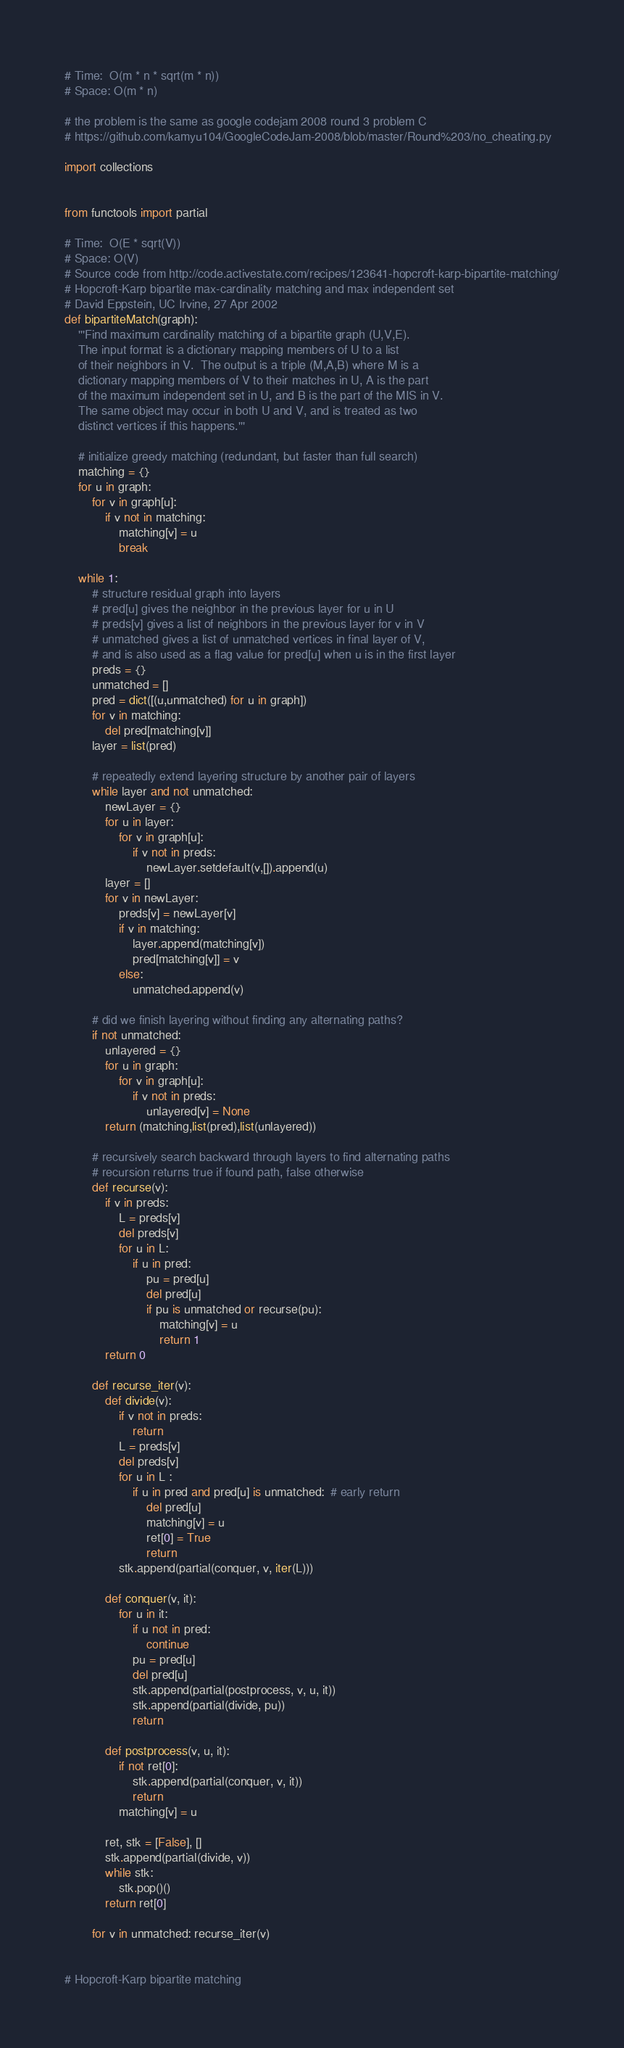Convert code to text. <code><loc_0><loc_0><loc_500><loc_500><_Python_># Time:  O(m * n * sqrt(m * n))
# Space: O(m * n)

# the problem is the same as google codejam 2008 round 3 problem C
# https://github.com/kamyu104/GoogleCodeJam-2008/blob/master/Round%203/no_cheating.py

import collections


from functools import partial

# Time:  O(E * sqrt(V))
# Space: O(V)
# Source code from http://code.activestate.com/recipes/123641-hopcroft-karp-bipartite-matching/
# Hopcroft-Karp bipartite max-cardinality matching and max independent set
# David Eppstein, UC Irvine, 27 Apr 2002
def bipartiteMatch(graph):
    '''Find maximum cardinality matching of a bipartite graph (U,V,E).
    The input format is a dictionary mapping members of U to a list
    of their neighbors in V.  The output is a triple (M,A,B) where M is a
    dictionary mapping members of V to their matches in U, A is the part
    of the maximum independent set in U, and B is the part of the MIS in V.
    The same object may occur in both U and V, and is treated as two
    distinct vertices if this happens.'''
    
    # initialize greedy matching (redundant, but faster than full search)
    matching = {}
    for u in graph:
        for v in graph[u]:
            if v not in matching:
                matching[v] = u
                break
    
    while 1:
        # structure residual graph into layers
        # pred[u] gives the neighbor in the previous layer for u in U
        # preds[v] gives a list of neighbors in the previous layer for v in V
        # unmatched gives a list of unmatched vertices in final layer of V,
        # and is also used as a flag value for pred[u] when u is in the first layer
        preds = {}
        unmatched = []
        pred = dict([(u,unmatched) for u in graph])
        for v in matching:
            del pred[matching[v]]
        layer = list(pred)
        
        # repeatedly extend layering structure by another pair of layers
        while layer and not unmatched:
            newLayer = {}
            for u in layer:
                for v in graph[u]:
                    if v not in preds:
                        newLayer.setdefault(v,[]).append(u)
            layer = []
            for v in newLayer:
                preds[v] = newLayer[v]
                if v in matching:
                    layer.append(matching[v])
                    pred[matching[v]] = v
                else:
                    unmatched.append(v)
        
        # did we finish layering without finding any alternating paths?
        if not unmatched:
            unlayered = {}
            for u in graph:
                for v in graph[u]:
                    if v not in preds:
                        unlayered[v] = None
            return (matching,list(pred),list(unlayered))

        # recursively search backward through layers to find alternating paths
        # recursion returns true if found path, false otherwise
        def recurse(v):
            if v in preds:
                L = preds[v]
                del preds[v]
                for u in L:
                    if u in pred:
                        pu = pred[u]
                        del pred[u]
                        if pu is unmatched or recurse(pu):
                            matching[v] = u
                            return 1
            return 0
        
        def recurse_iter(v):
            def divide(v):
                if v not in preds:
                    return
                L = preds[v]
                del preds[v]
                for u in L :
                    if u in pred and pred[u] is unmatched:  # early return
                        del pred[u]
                        matching[v] = u
                        ret[0] = True
                        return
                stk.append(partial(conquer, v, iter(L)))

            def conquer(v, it):
                for u in it:
                    if u not in pred:
                        continue
                    pu = pred[u]
                    del pred[u]
                    stk.append(partial(postprocess, v, u, it))
                    stk.append(partial(divide, pu))
                    return

            def postprocess(v, u, it):
                if not ret[0]:
                    stk.append(partial(conquer, v, it))
                    return
                matching[v] = u

            ret, stk = [False], []
            stk.append(partial(divide, v))
            while stk:
                stk.pop()()
            return ret[0]

        for v in unmatched: recurse_iter(v)


# Hopcroft-Karp bipartite matching</code> 